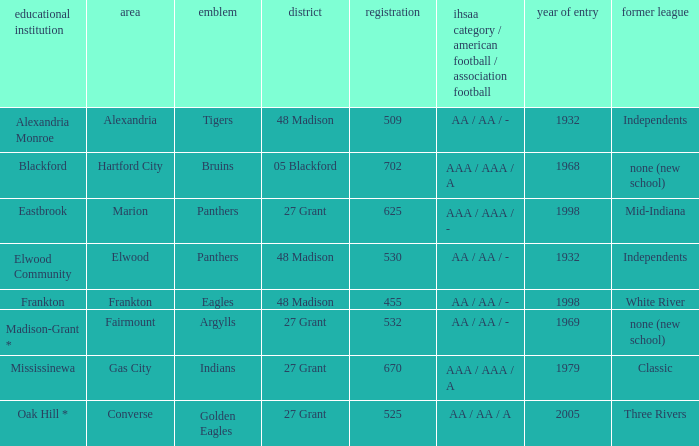What is the school with the location of alexandria? Alexandria Monroe. 